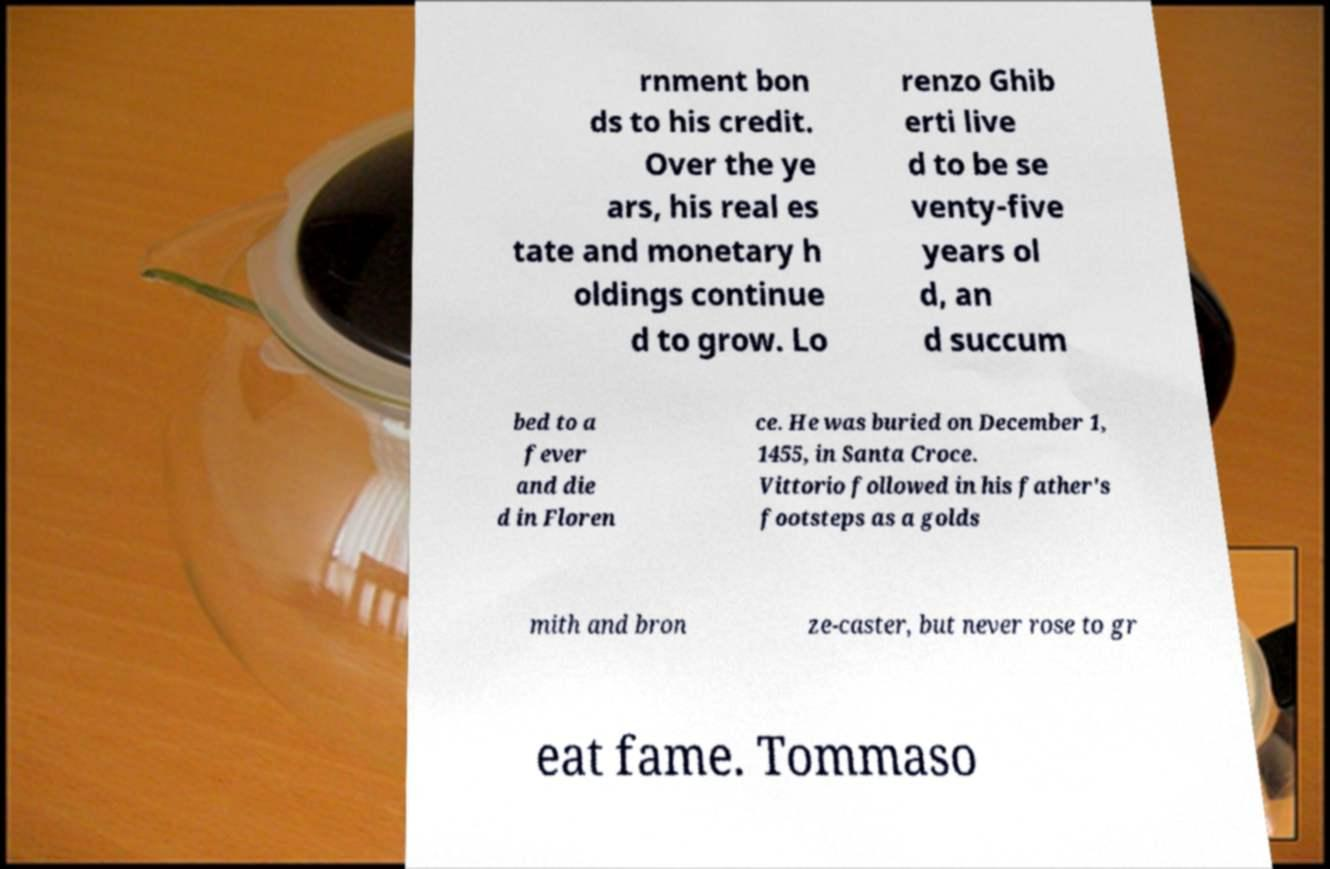Could you assist in decoding the text presented in this image and type it out clearly? rnment bon ds to his credit. Over the ye ars, his real es tate and monetary h oldings continue d to grow. Lo renzo Ghib erti live d to be se venty-five years ol d, an d succum bed to a fever and die d in Floren ce. He was buried on December 1, 1455, in Santa Croce. Vittorio followed in his father's footsteps as a golds mith and bron ze-caster, but never rose to gr eat fame. Tommaso 